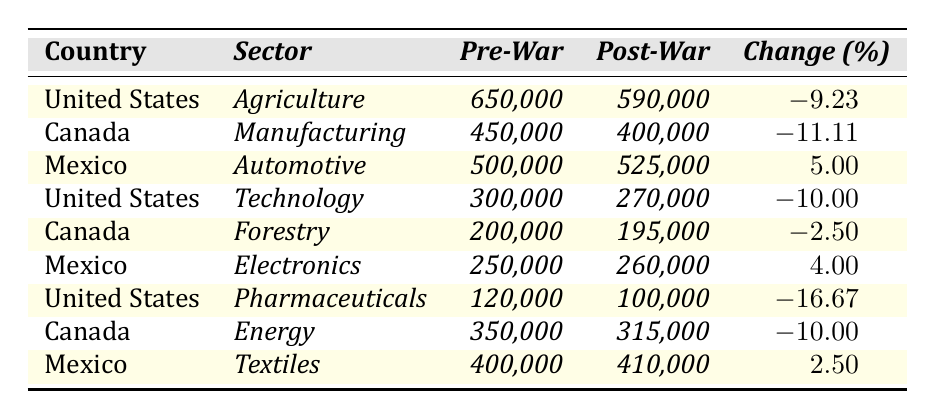What is the post-trade war volume for the United States in the Agriculture sector? The table indicates that the post-trade war volume for the United States in the Agriculture sector is listed as 590,000.
Answer: 590,000 Which country experienced the largest percentage decline in trade volume post-trade war? By comparing the change percentages in the table, the United States in the Pharmaceuticals sector had the largest decline at -16.67%.
Answer: United States (Pharmaceuticals) What was the total trade volume for Mexico across all sectors pre-trade war? Adding the pre-trade volumes for Mexico in Automotive (500,000), Electronics (250,000), and Textiles (400,000) gives a total of 1,150,000.
Answer: 1,150,000 Is the change in trade volume for Canada in the Forestry sector positive or negative? The change percentage for Canada in the Forestry sector is -2.50%, indicating a decline in trade volume.
Answer: Negative What is the average change percentage of trade volume for all countries in the table? The average change percentage is calculated by summing the change percentages (-9.23, -11.11, 5.00, -10.00, -2.50, 4.00, -16.67, -10.00, 2.50), resulting in -1.78% when divided by 9 data points.
Answer: -1.78% Which sector saw an increase in trade volume for Mexico post-trade war? The Automotive sector (5.00% increase) and the Electronics sector (4.00% increase) both saw an increase in trade volume for Mexico.
Answer: Automotive and Electronics For Canada, what was the change in trade volume in the Energy sector? The table shows that for Canada, the pre-trade war volume was 350,000 and the post-trade war volume was 315,000, indicating a decline of 10,000.
Answer: Decline of 10,000 Did the trade volume for Mexico in the Textiles sector change positively or negatively post-trade war? According to the data, the trade volume in the Textiles sector for Mexico increased by 2.50%.
Answer: Positively Which country had a trade volume decrease in both Agriculture and Technology sectors? The United States experienced a decrease in trade volume in both the Agriculture sector (-9.23%) and the Technology sector (-10.00%).
Answer: United States What is the difference in trade volume for Canada in the Manufacturing sector pre- and post-trade war? The difference is calculated by subtracting the post-trade war volume (400,000) from the pre-trade war volume (450,000), which results in a decrease of 50,000.
Answer: 50,000 What proportion of the total trade volume in the Automotive sector is represented by Mexico's post-trade war volume? Mexico's post-trade war volume in the Automotive sector is 525,000. The total (including United States and Canada) can be calculated as follows: United States (automotive not listed) + Canada (automotive not listed) + Mexico (525,000), hence, it's not possible to find proportion without total data.
Answer: Not calculable with available data 